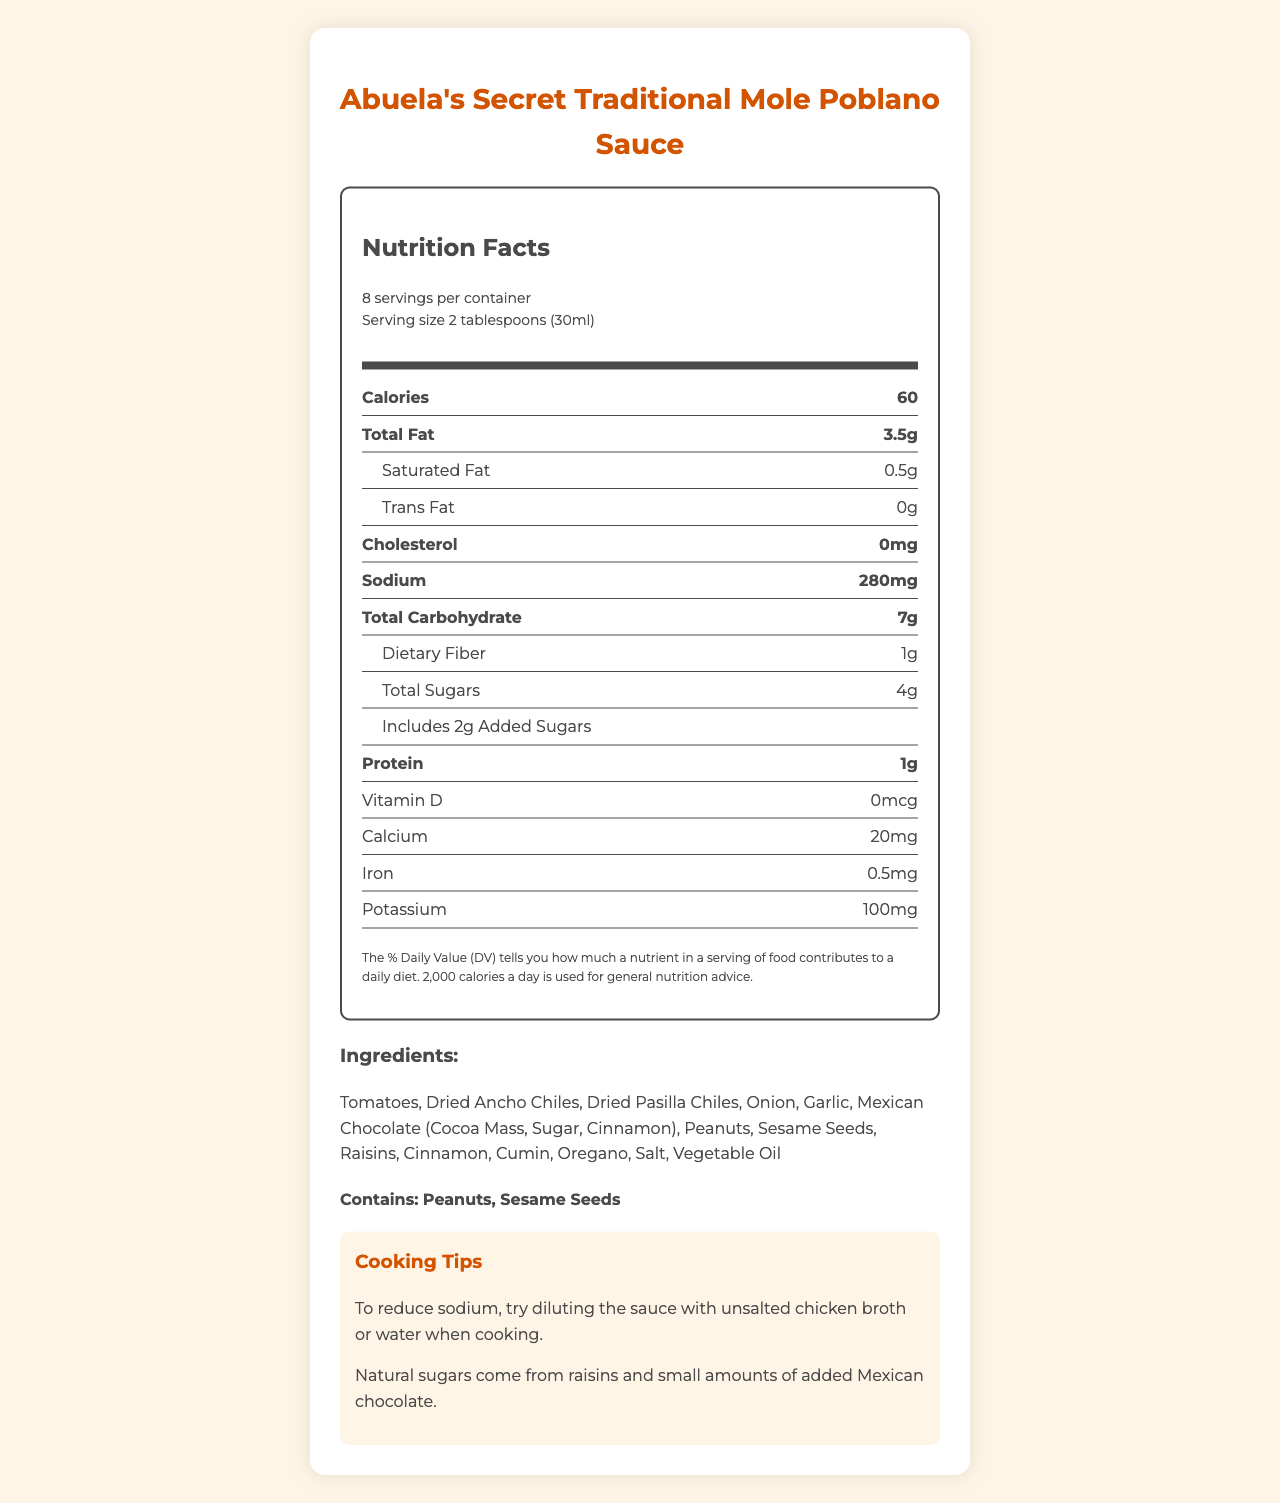what is the serving size of the sauce? The serving size is clearly mentioned as "2 tablespoons (30ml)" in the document.
Answer: 2 tablespoons (30ml) how much sodium is in one serving? The document states that each serving contains 280 milligrams of sodium.
Answer: 280 milligrams what are the main sources of sugar in the mole sauce? The document explains that natural sugars come from raisins, and small amounts are added through Mexican chocolate.
Answer: Raisins and Mexican chocolate how many grams of added sugars are there per serving? The document states that there are 2 grams of added sugars per serving.
Answer: 2 grams which two ingredients may cause allergic reactions? The document lists peanuts and sesame seeds as allergens.
Answer: Peanuts and sesame seeds which ingredient is not part of the sauce? A. Garlic B. Cinnamon C. Milk D. Onion The document lists various ingredients, but milk is not included.
Answer: C: Milk how can you reduce sodium when using this mole sauce? A. Use salt B. Add more sauce C. Dilute with unsalted chicken broth or water The document provides a tip suggesting to dilute the sauce with unsalted chicken broth or water to reduce sodium.
Answer: C: Dilute with unsalted chicken broth or water how many calories are there per serving? The document lists 60 calories per serving.
Answer: 60 calories does the sauce contain any cholesterol? The document indicates that the sauce contains 0 milligrams of cholesterol.
Answer: No summarize the main information provided in this Nutrition Facts label. The document is a nutrition facts label for a traditional mole sauce, highlighting various nutritional components, ingredients, and cooking tips.
Answer: The document provides nutritional information for "Abuela's Secret Traditional Mole Poblano Sauce". It includes details about serving size, calories, fat, cholesterol, sodium, carbohydrates, sugars, protein, and vitamins. Ingredients and allergens are listed, and tips for reducing sodium and the sources of sugars are provided. how much dietary fiber is in a serving? The document states that there is 1 gram of dietary fiber per serving.
Answer: 1 gram is the sauce suitable for a peanut-free diet? The document lists peanuts as an allergen, indicating it's not suitable for a peanut-free diet.
Answer: No which option provides the most vitamin D per serving: the sauce, an egg, or a glass of milk? The document does not provide vitamin D values for eggs or milk, making this question unanswerable based on the available information.
Answer: Not enough information 